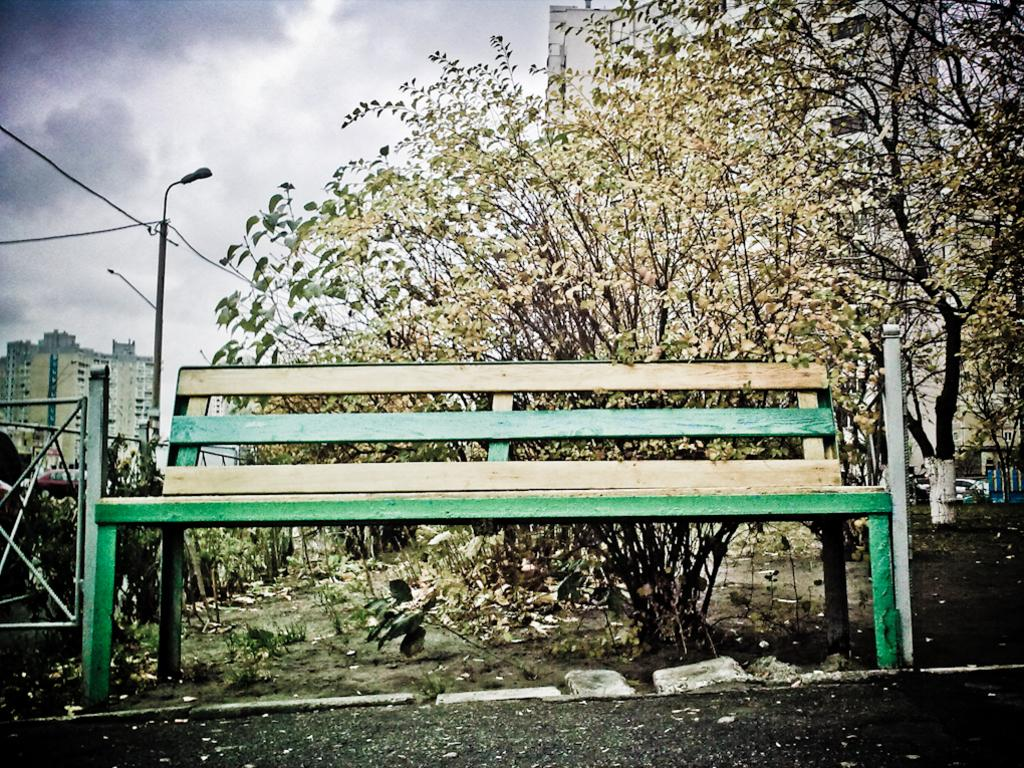What type of seating is present in the image? There is a bench in the image. Where is the bench located? The bench is on the ground. What can be seen behind the bench? There are trees behind the bench. What type of structures are visible in the image? There are buildings visible in the image. What is the tall, illuminated object in the image? There is a street light pole in the image. How many clovers can be seen growing near the bench in the image? There is no mention of clovers in the image, so it is not possible to determine their presence or quantity. 